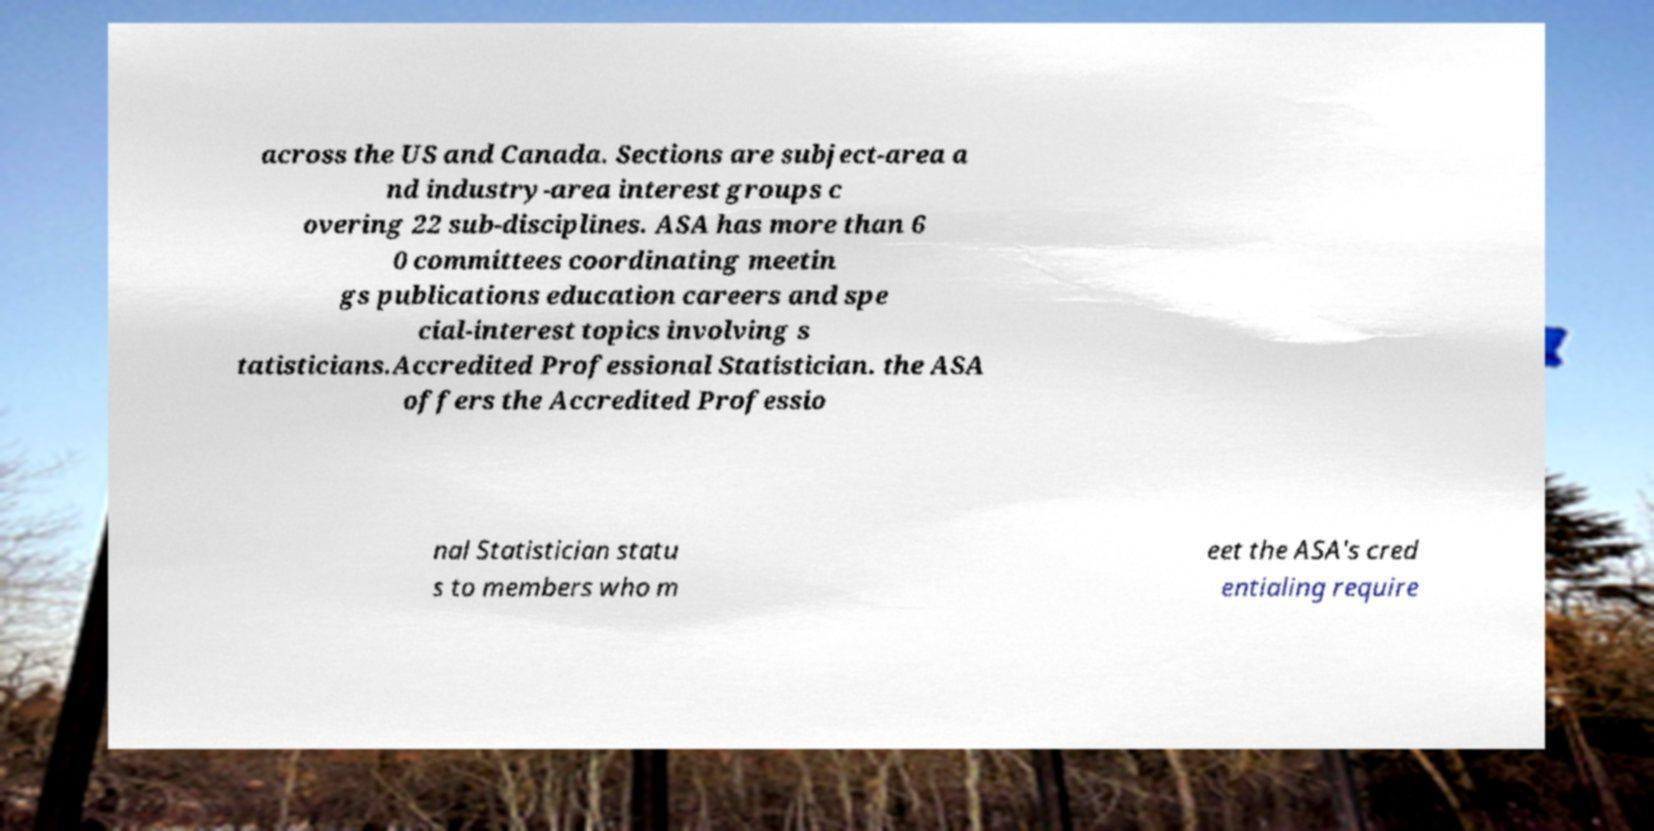Please read and relay the text visible in this image. What does it say? across the US and Canada. Sections are subject-area a nd industry-area interest groups c overing 22 sub-disciplines. ASA has more than 6 0 committees coordinating meetin gs publications education careers and spe cial-interest topics involving s tatisticians.Accredited Professional Statistician. the ASA offers the Accredited Professio nal Statistician statu s to members who m eet the ASA's cred entialing require 